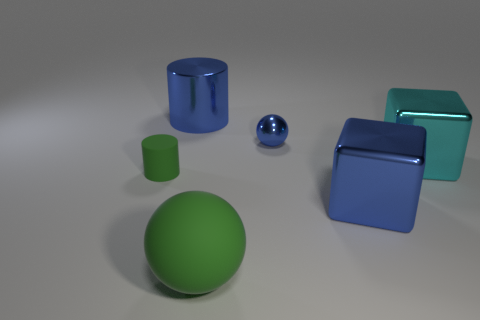Does the tiny metal thing have the same shape as the big green rubber object?
Your answer should be very brief. Yes. There is a tiny green object; does it have the same shape as the green matte thing that is in front of the tiny green matte thing?
Provide a succinct answer. No. What is the color of the big sphere that is on the right side of the thing left of the large object that is to the left of the large green sphere?
Your answer should be compact. Green. Is the shape of the tiny matte thing that is behind the big green ball the same as  the large cyan thing?
Give a very brief answer. No. What is the small cylinder made of?
Your answer should be compact. Rubber. What is the shape of the blue metallic thing on the right side of the small object that is to the right of the big blue object that is left of the large blue block?
Offer a terse response. Cube. How many other objects are the same shape as the large matte object?
Offer a terse response. 1. Does the small metallic ball have the same color as the tiny thing to the left of the green matte ball?
Provide a succinct answer. No. What number of big blue things are there?
Provide a succinct answer. 2. What number of objects are gray cylinders or matte things?
Make the answer very short. 2. 